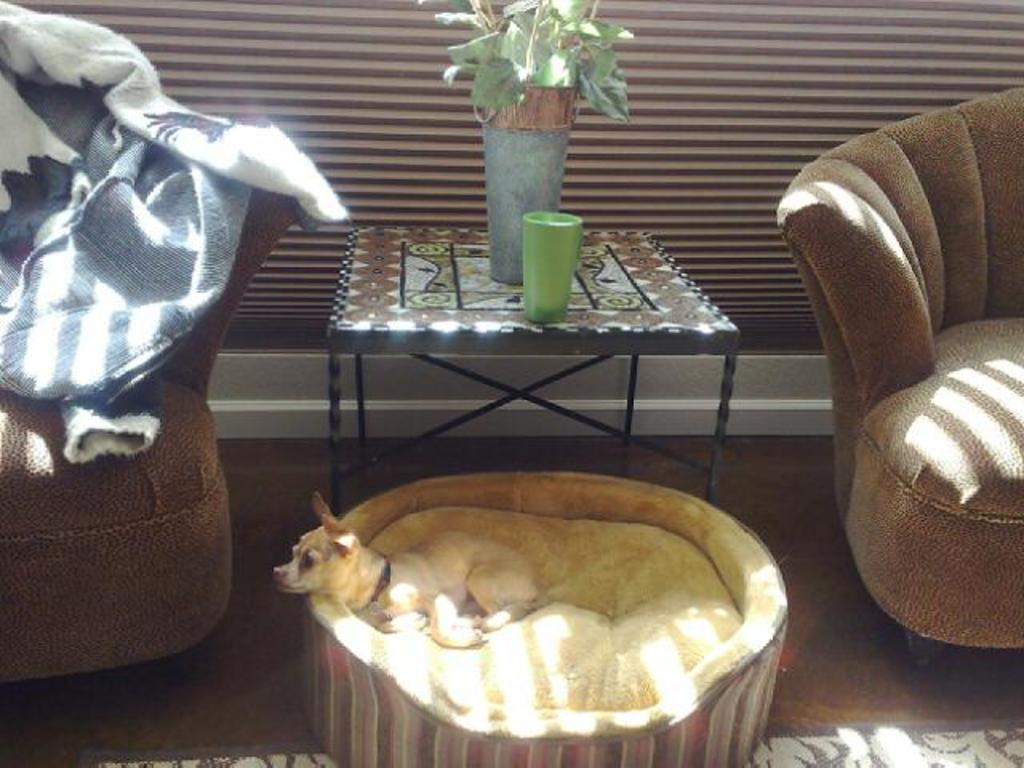How many sofas are in the room? There are two sofas in the room. What is the dog in the room doing? The dog is sleeping on its bed. What is on the table in the room? There is a flower pot and a glass placed on the table. What can be seen in the background of the room? There is a wall in the background of the room. What type of steel is used to construct the dog's bed in the image? There is no mention of steel or any construction material in the image; the dog's bed is not described in detail. What is the rate of the dog's breathing while it is sleeping? The image does not provide information about the dog's breathing rate; it only shows the dog sleeping on its bed. 